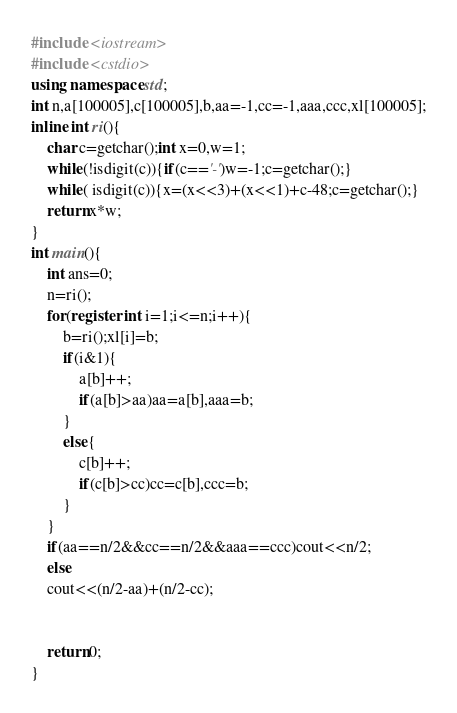<code> <loc_0><loc_0><loc_500><loc_500><_C++_>#include <iostream>
#include <cstdio>
using namespace std;
int n,a[100005],c[100005],b,aa=-1,cc=-1,aaa,ccc,xl[100005];
inline int ri(){
	char c=getchar();int x=0,w=1;
	while(!isdigit(c)){if(c=='-')w=-1;c=getchar();}
	while( isdigit(c)){x=(x<<3)+(x<<1)+c-48;c=getchar();}
	return x*w;
}
int main(){
	int ans=0;
	n=ri();
	for(register int i=1;i<=n;i++){
		b=ri();xl[i]=b;
		if(i&1){
			a[b]++;
			if(a[b]>aa)aa=a[b],aaa=b;
		}
		else{
			c[b]++;
			if(c[b]>cc)cc=c[b],ccc=b;
		} 
	}
	if(aa==n/2&&cc==n/2&&aaa==ccc)cout<<n/2;
	else 
	cout<<(n/2-aa)+(n/2-cc);
	
	
	return 0;
} </code> 